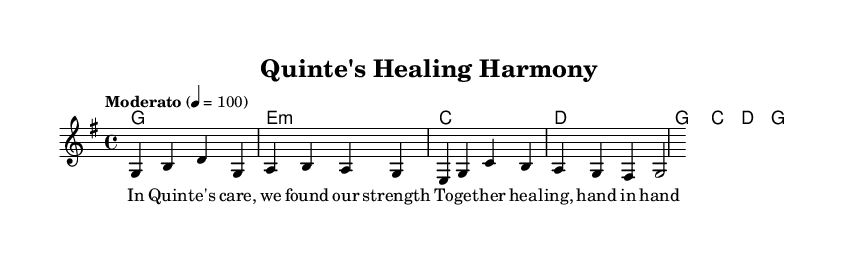What is the key signature of this music? The key signature is G major, which includes one sharp (F#). This can be recognized by looking at the key signature at the beginning of the staff where there is a single sharp indicated.
Answer: G major What is the time signature of the piece? The time signature is 4/4, which means there are four beats per measure and the quarter note gets one beat. This is seen at the beginning of the notation right after the key signature marking.
Answer: 4/4 What is the tempo marking for the piece? The tempo marking is "Moderato" at a speed of quarter note equals 100 beats per minute. This is given in the tempo instruction notation at the start of the music.
Answer: Moderato 4 = 100 How many measures are in the given melody? The melody consists of 4 measures. Each measure is separated by vertical bar lines, and counting each separate section reveals this total.
Answer: 4 What is the first note of the melody? The first note of the melody is G. This can be found at the beginning of the melody line, where the first note is located.
Answer: G What do the lyrics in the verse express? The lyrics express themes of healing and support within the community, emphasizing togetherness and strength in care. This is derived from analyzing the wording of the lyrics provided for the melody.
Answer: Healing and support How do the harmonies relate to the melody? The harmonies provide a supporting backdrop to the melody, where each chord aligns with the melody notes, enhancing the overall sound. This can be observed by looking at the chord symbols which correlate with the notes in the melody line.
Answer: They complement the melody 